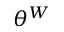<formula> <loc_0><loc_0><loc_500><loc_500>\theta ^ { W }</formula> 